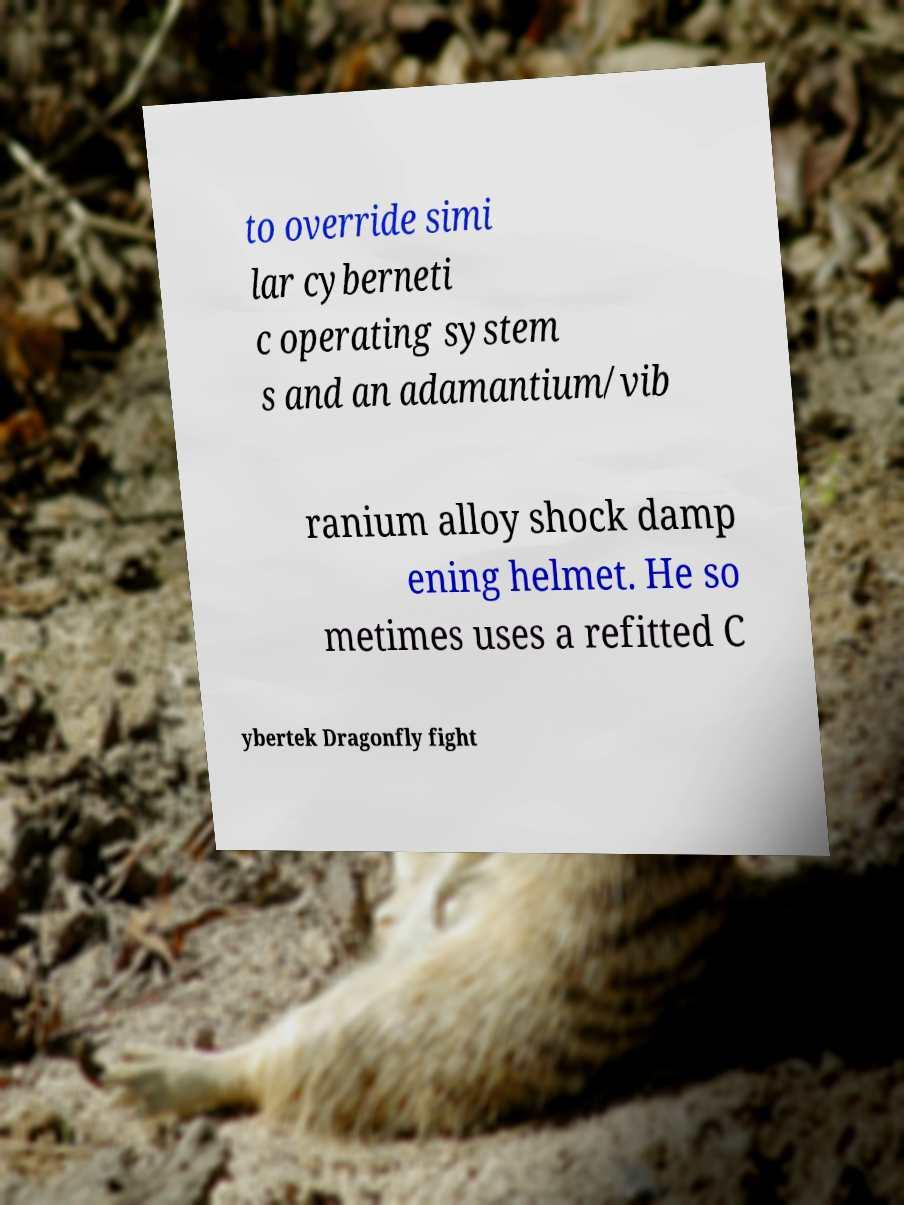There's text embedded in this image that I need extracted. Can you transcribe it verbatim? to override simi lar cyberneti c operating system s and an adamantium/vib ranium alloy shock damp ening helmet. He so metimes uses a refitted C ybertek Dragonfly fight 